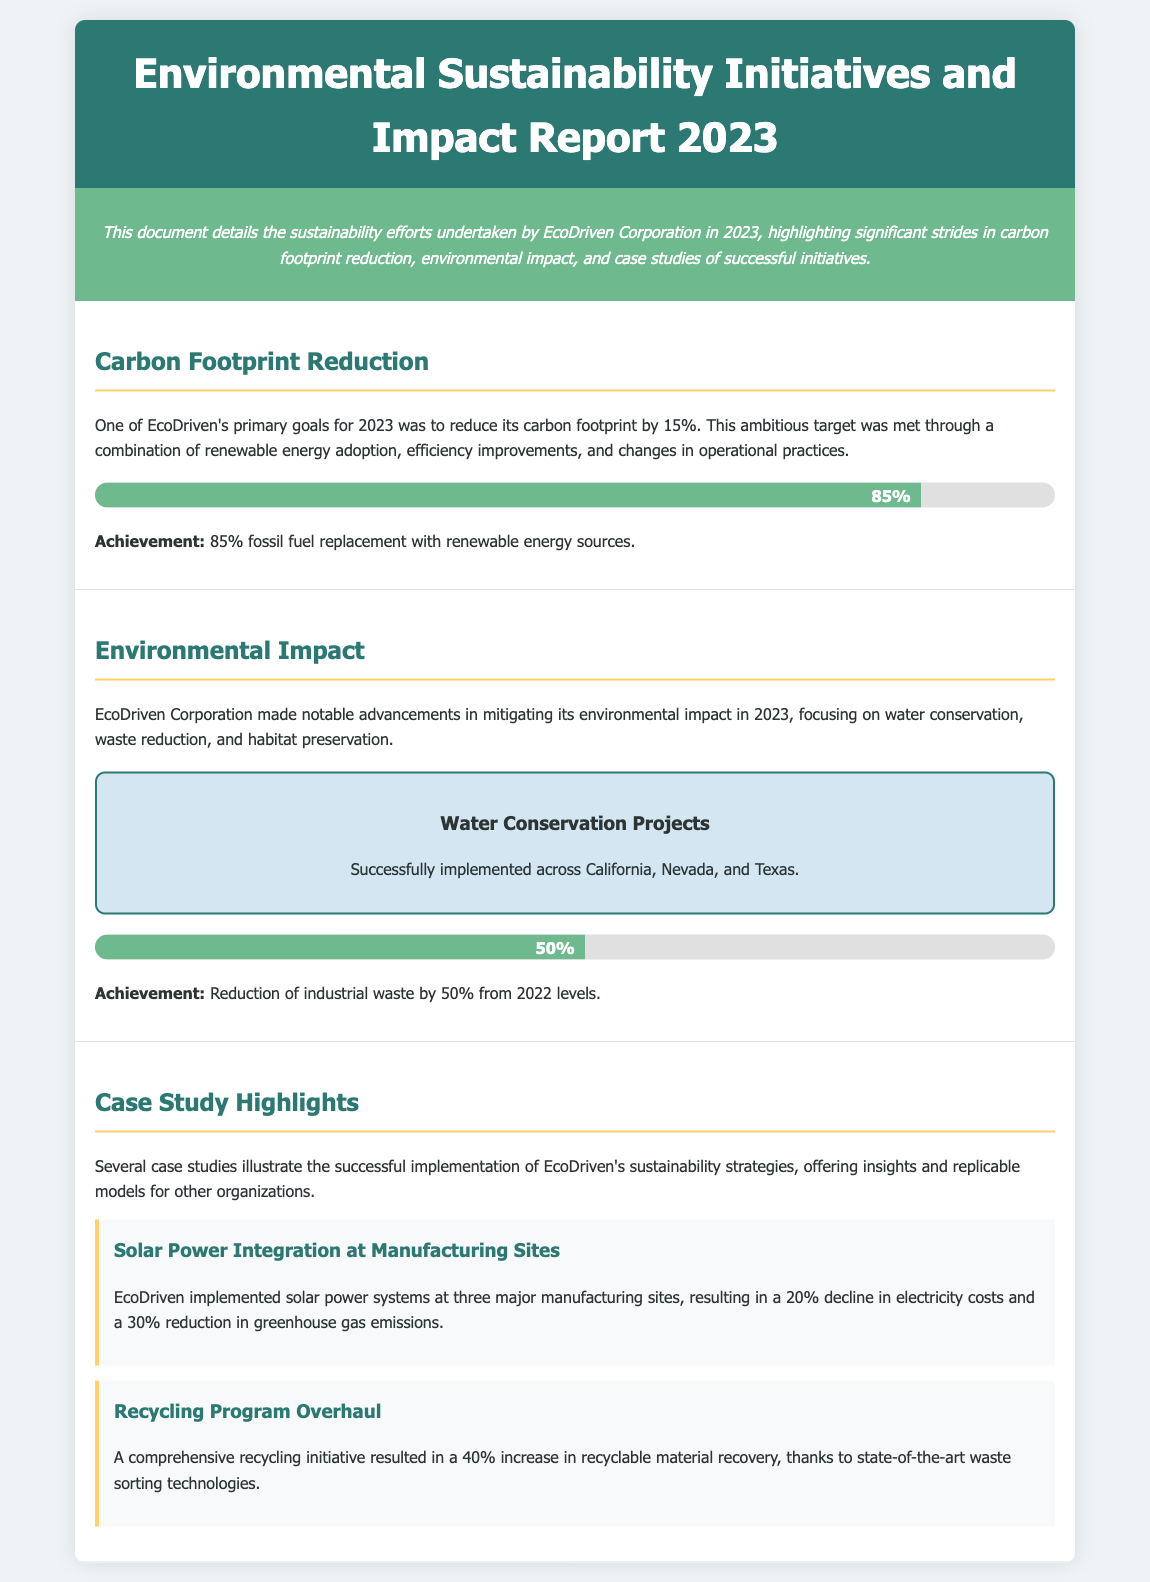What was EcoDriven's carbon footprint reduction target for 2023? The document states that EcoDriven aimed to reduce its carbon footprint by 15% in 2023.
Answer: 15% What percentage of fossil fuel was replaced with renewable energy? The achievement mentioned in the carbon footprint reduction section indicates that 85% of fossil fuel was replaced with renewable energy sources.
Answer: 85% What percentage reduction in industrial waste was achieved? The document highlights a 50% reduction in industrial waste from 2022 levels.
Answer: 50% Which states had water conservation projects implemented? The water conservation projects were successfully implemented across California, Nevada, and Texas, as mentioned in the document.
Answer: California, Nevada, Texas What decline in electricity costs resulted from the solar power integration case study? The solar power integration case study reports a 20% decline in electricity costs at the manufacturing sites.
Answer: 20% What is the increase in recyclable material recovery due to the recycling program overhaul? The document states that there was a 40% increase in recyclable material recovery from the recycling program overhaul.
Answer: 40% What type of systems did EcoDriven implement at manufacturing sites? The document specifies that solar power systems were implemented at three major manufacturing sites.
Answer: Solar power systems How many manufacturing sites were involved in the solar power integration case study? According to the case study, three major manufacturing sites were involved in the solar power integration.
Answer: Three What strategies are illustrated in the case studies? The case studies illustrate successful implementation of EcoDriven's sustainability strategies.
Answer: Sustainability strategies 